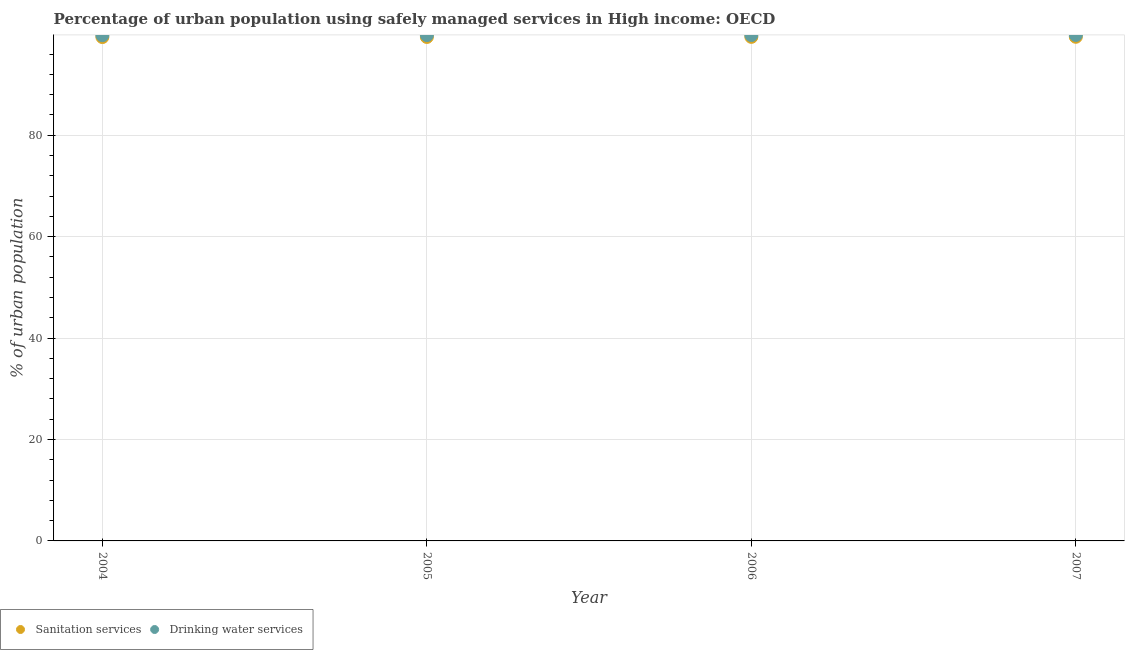How many different coloured dotlines are there?
Your response must be concise. 2. Is the number of dotlines equal to the number of legend labels?
Make the answer very short. Yes. What is the percentage of urban population who used drinking water services in 2006?
Your answer should be very brief. 99.76. Across all years, what is the maximum percentage of urban population who used drinking water services?
Give a very brief answer. 99.78. Across all years, what is the minimum percentage of urban population who used sanitation services?
Give a very brief answer. 99.37. In which year was the percentage of urban population who used sanitation services maximum?
Provide a succinct answer. 2007. What is the total percentage of urban population who used drinking water services in the graph?
Your answer should be very brief. 399.02. What is the difference between the percentage of urban population who used drinking water services in 2006 and that in 2007?
Your answer should be compact. -0.02. What is the difference between the percentage of urban population who used sanitation services in 2007 and the percentage of urban population who used drinking water services in 2004?
Ensure brevity in your answer.  -0.31. What is the average percentage of urban population who used sanitation services per year?
Give a very brief answer. 99.39. In the year 2007, what is the difference between the percentage of urban population who used sanitation services and percentage of urban population who used drinking water services?
Keep it short and to the point. -0.36. What is the ratio of the percentage of urban population who used drinking water services in 2005 to that in 2007?
Make the answer very short. 1. What is the difference between the highest and the second highest percentage of urban population who used sanitation services?
Offer a very short reply. 0.02. What is the difference between the highest and the lowest percentage of urban population who used drinking water services?
Ensure brevity in your answer.  0.04. Is the sum of the percentage of urban population who used sanitation services in 2004 and 2007 greater than the maximum percentage of urban population who used drinking water services across all years?
Give a very brief answer. Yes. Does the percentage of urban population who used sanitation services monotonically increase over the years?
Provide a succinct answer. Yes. What is the difference between two consecutive major ticks on the Y-axis?
Make the answer very short. 20. Are the values on the major ticks of Y-axis written in scientific E-notation?
Give a very brief answer. No. Does the graph contain any zero values?
Offer a very short reply. No. How many legend labels are there?
Your answer should be very brief. 2. How are the legend labels stacked?
Your response must be concise. Horizontal. What is the title of the graph?
Your response must be concise. Percentage of urban population using safely managed services in High income: OECD. Does "Goods" appear as one of the legend labels in the graph?
Provide a succinct answer. No. What is the label or title of the X-axis?
Give a very brief answer. Year. What is the label or title of the Y-axis?
Your answer should be compact. % of urban population. What is the % of urban population in Sanitation services in 2004?
Your answer should be compact. 99.37. What is the % of urban population in Drinking water services in 2004?
Keep it short and to the point. 99.73. What is the % of urban population of Sanitation services in 2005?
Give a very brief answer. 99.39. What is the % of urban population in Drinking water services in 2005?
Your answer should be very brief. 99.75. What is the % of urban population of Sanitation services in 2006?
Your response must be concise. 99.4. What is the % of urban population of Drinking water services in 2006?
Make the answer very short. 99.76. What is the % of urban population of Sanitation services in 2007?
Provide a short and direct response. 99.42. What is the % of urban population of Drinking water services in 2007?
Give a very brief answer. 99.78. Across all years, what is the maximum % of urban population of Sanitation services?
Offer a very short reply. 99.42. Across all years, what is the maximum % of urban population in Drinking water services?
Keep it short and to the point. 99.78. Across all years, what is the minimum % of urban population of Sanitation services?
Give a very brief answer. 99.37. Across all years, what is the minimum % of urban population in Drinking water services?
Your response must be concise. 99.73. What is the total % of urban population in Sanitation services in the graph?
Provide a short and direct response. 397.58. What is the total % of urban population of Drinking water services in the graph?
Ensure brevity in your answer.  399.02. What is the difference between the % of urban population in Sanitation services in 2004 and that in 2005?
Offer a terse response. -0.02. What is the difference between the % of urban population in Drinking water services in 2004 and that in 2005?
Keep it short and to the point. -0.02. What is the difference between the % of urban population in Sanitation services in 2004 and that in 2006?
Your answer should be compact. -0.04. What is the difference between the % of urban population in Drinking water services in 2004 and that in 2006?
Make the answer very short. -0.03. What is the difference between the % of urban population of Sanitation services in 2004 and that in 2007?
Give a very brief answer. -0.05. What is the difference between the % of urban population of Drinking water services in 2004 and that in 2007?
Make the answer very short. -0.04. What is the difference between the % of urban population in Sanitation services in 2005 and that in 2006?
Offer a very short reply. -0.02. What is the difference between the % of urban population in Drinking water services in 2005 and that in 2006?
Offer a terse response. -0.01. What is the difference between the % of urban population in Sanitation services in 2005 and that in 2007?
Your answer should be very brief. -0.03. What is the difference between the % of urban population of Drinking water services in 2005 and that in 2007?
Keep it short and to the point. -0.03. What is the difference between the % of urban population in Sanitation services in 2006 and that in 2007?
Make the answer very short. -0.02. What is the difference between the % of urban population of Drinking water services in 2006 and that in 2007?
Offer a terse response. -0.02. What is the difference between the % of urban population in Sanitation services in 2004 and the % of urban population in Drinking water services in 2005?
Provide a succinct answer. -0.38. What is the difference between the % of urban population of Sanitation services in 2004 and the % of urban population of Drinking water services in 2006?
Your answer should be very brief. -0.39. What is the difference between the % of urban population in Sanitation services in 2004 and the % of urban population in Drinking water services in 2007?
Keep it short and to the point. -0.41. What is the difference between the % of urban population in Sanitation services in 2005 and the % of urban population in Drinking water services in 2006?
Offer a terse response. -0.37. What is the difference between the % of urban population in Sanitation services in 2005 and the % of urban population in Drinking water services in 2007?
Provide a short and direct response. -0.39. What is the difference between the % of urban population of Sanitation services in 2006 and the % of urban population of Drinking water services in 2007?
Your answer should be very brief. -0.37. What is the average % of urban population of Sanitation services per year?
Your answer should be compact. 99.39. What is the average % of urban population of Drinking water services per year?
Give a very brief answer. 99.75. In the year 2004, what is the difference between the % of urban population in Sanitation services and % of urban population in Drinking water services?
Keep it short and to the point. -0.36. In the year 2005, what is the difference between the % of urban population of Sanitation services and % of urban population of Drinking water services?
Give a very brief answer. -0.36. In the year 2006, what is the difference between the % of urban population of Sanitation services and % of urban population of Drinking water services?
Your response must be concise. -0.36. In the year 2007, what is the difference between the % of urban population of Sanitation services and % of urban population of Drinking water services?
Keep it short and to the point. -0.36. What is the ratio of the % of urban population in Sanitation services in 2004 to that in 2005?
Your answer should be compact. 1. What is the ratio of the % of urban population of Sanitation services in 2004 to that in 2006?
Your answer should be very brief. 1. What is the ratio of the % of urban population of Drinking water services in 2004 to that in 2006?
Provide a succinct answer. 1. What is the ratio of the % of urban population of Sanitation services in 2005 to that in 2006?
Keep it short and to the point. 1. What is the ratio of the % of urban population in Drinking water services in 2005 to that in 2006?
Ensure brevity in your answer.  1. What is the ratio of the % of urban population in Sanitation services in 2005 to that in 2007?
Keep it short and to the point. 1. What is the difference between the highest and the second highest % of urban population of Sanitation services?
Provide a short and direct response. 0.02. What is the difference between the highest and the second highest % of urban population in Drinking water services?
Your answer should be compact. 0.02. What is the difference between the highest and the lowest % of urban population in Sanitation services?
Your answer should be very brief. 0.05. What is the difference between the highest and the lowest % of urban population in Drinking water services?
Provide a succinct answer. 0.04. 